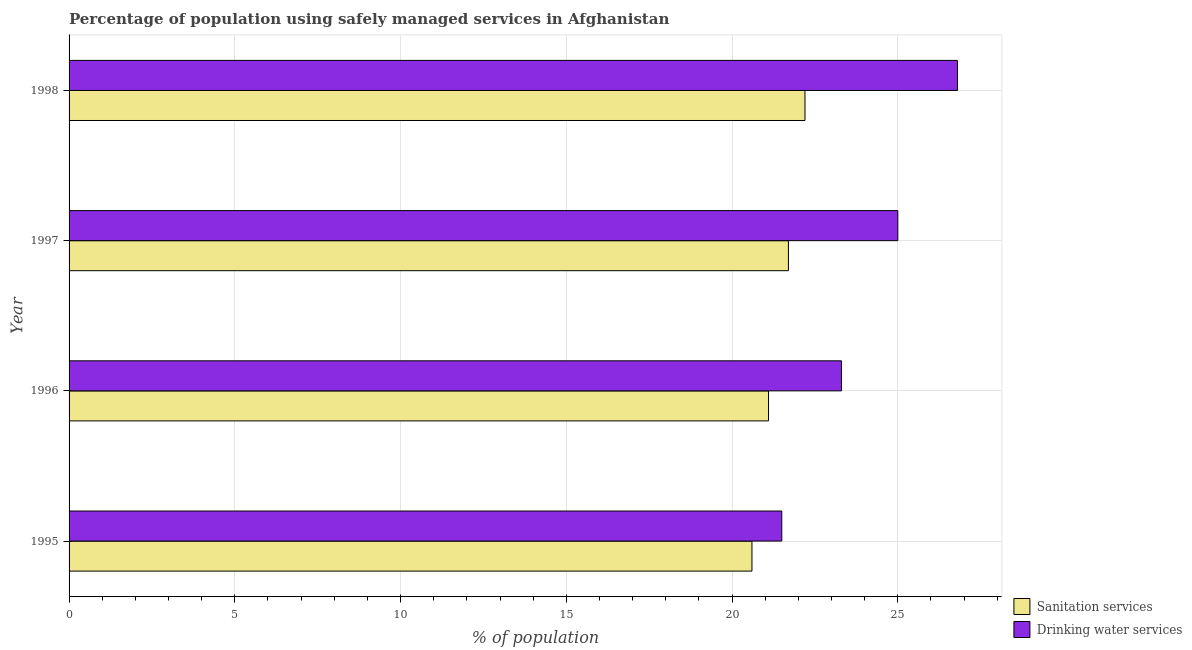How many different coloured bars are there?
Offer a very short reply. 2. Are the number of bars per tick equal to the number of legend labels?
Provide a succinct answer. Yes. Are the number of bars on each tick of the Y-axis equal?
Provide a succinct answer. Yes. In how many cases, is the number of bars for a given year not equal to the number of legend labels?
Offer a terse response. 0. What is the percentage of population who used drinking water services in 1997?
Your response must be concise. 25. Across all years, what is the maximum percentage of population who used drinking water services?
Provide a short and direct response. 26.8. Across all years, what is the minimum percentage of population who used sanitation services?
Give a very brief answer. 20.6. In which year was the percentage of population who used drinking water services minimum?
Ensure brevity in your answer.  1995. What is the total percentage of population who used sanitation services in the graph?
Offer a terse response. 85.6. What is the difference between the percentage of population who used sanitation services in 1997 and the percentage of population who used drinking water services in 1996?
Ensure brevity in your answer.  -1.6. What is the average percentage of population who used drinking water services per year?
Give a very brief answer. 24.15. In the year 1996, what is the difference between the percentage of population who used sanitation services and percentage of population who used drinking water services?
Give a very brief answer. -2.2. In how many years, is the percentage of population who used sanitation services greater than 17 %?
Make the answer very short. 4. What is the ratio of the percentage of population who used drinking water services in 1996 to that in 1997?
Your answer should be very brief. 0.93. Is the percentage of population who used sanitation services in 1995 less than that in 1998?
Offer a terse response. Yes. Is the sum of the percentage of population who used drinking water services in 1995 and 1998 greater than the maximum percentage of population who used sanitation services across all years?
Offer a very short reply. Yes. What does the 1st bar from the top in 1998 represents?
Give a very brief answer. Drinking water services. What does the 1st bar from the bottom in 1996 represents?
Offer a terse response. Sanitation services. How many bars are there?
Keep it short and to the point. 8. Are all the bars in the graph horizontal?
Ensure brevity in your answer.  Yes. How many years are there in the graph?
Your response must be concise. 4. What is the difference between two consecutive major ticks on the X-axis?
Provide a succinct answer. 5. Are the values on the major ticks of X-axis written in scientific E-notation?
Keep it short and to the point. No. Does the graph contain any zero values?
Keep it short and to the point. No. Where does the legend appear in the graph?
Offer a very short reply. Bottom right. What is the title of the graph?
Provide a succinct answer. Percentage of population using safely managed services in Afghanistan. Does "International Tourists" appear as one of the legend labels in the graph?
Your answer should be compact. No. What is the label or title of the X-axis?
Your answer should be compact. % of population. What is the % of population in Sanitation services in 1995?
Your answer should be very brief. 20.6. What is the % of population of Drinking water services in 1995?
Your answer should be very brief. 21.5. What is the % of population of Sanitation services in 1996?
Your response must be concise. 21.1. What is the % of population in Drinking water services in 1996?
Your answer should be very brief. 23.3. What is the % of population in Sanitation services in 1997?
Your answer should be very brief. 21.7. What is the % of population of Drinking water services in 1997?
Your answer should be very brief. 25. What is the % of population in Sanitation services in 1998?
Ensure brevity in your answer.  22.2. What is the % of population in Drinking water services in 1998?
Your answer should be compact. 26.8. Across all years, what is the maximum % of population of Sanitation services?
Your answer should be compact. 22.2. Across all years, what is the maximum % of population in Drinking water services?
Your response must be concise. 26.8. Across all years, what is the minimum % of population in Sanitation services?
Make the answer very short. 20.6. Across all years, what is the minimum % of population of Drinking water services?
Provide a short and direct response. 21.5. What is the total % of population in Sanitation services in the graph?
Ensure brevity in your answer.  85.6. What is the total % of population of Drinking water services in the graph?
Provide a short and direct response. 96.6. What is the difference between the % of population of Sanitation services in 1995 and that in 1998?
Offer a very short reply. -1.6. What is the difference between the % of population of Drinking water services in 1995 and that in 1998?
Your answer should be compact. -5.3. What is the difference between the % of population of Sanitation services in 1996 and that in 1997?
Give a very brief answer. -0.6. What is the difference between the % of population in Drinking water services in 1996 and that in 1997?
Your answer should be compact. -1.7. What is the difference between the % of population of Sanitation services in 1996 and that in 1998?
Ensure brevity in your answer.  -1.1. What is the difference between the % of population in Sanitation services in 1995 and the % of population in Drinking water services in 1996?
Make the answer very short. -2.7. What is the difference between the % of population of Sanitation services in 1995 and the % of population of Drinking water services in 1997?
Ensure brevity in your answer.  -4.4. What is the difference between the % of population of Sanitation services in 1995 and the % of population of Drinking water services in 1998?
Give a very brief answer. -6.2. What is the difference between the % of population of Sanitation services in 1996 and the % of population of Drinking water services in 1997?
Keep it short and to the point. -3.9. What is the average % of population of Sanitation services per year?
Make the answer very short. 21.4. What is the average % of population of Drinking water services per year?
Ensure brevity in your answer.  24.15. In the year 1997, what is the difference between the % of population in Sanitation services and % of population in Drinking water services?
Offer a terse response. -3.3. In the year 1998, what is the difference between the % of population in Sanitation services and % of population in Drinking water services?
Make the answer very short. -4.6. What is the ratio of the % of population of Sanitation services in 1995 to that in 1996?
Ensure brevity in your answer.  0.98. What is the ratio of the % of population of Drinking water services in 1995 to that in 1996?
Provide a succinct answer. 0.92. What is the ratio of the % of population in Sanitation services in 1995 to that in 1997?
Provide a short and direct response. 0.95. What is the ratio of the % of population of Drinking water services in 1995 to that in 1997?
Your answer should be very brief. 0.86. What is the ratio of the % of population of Sanitation services in 1995 to that in 1998?
Ensure brevity in your answer.  0.93. What is the ratio of the % of population of Drinking water services in 1995 to that in 1998?
Provide a short and direct response. 0.8. What is the ratio of the % of population of Sanitation services in 1996 to that in 1997?
Provide a succinct answer. 0.97. What is the ratio of the % of population in Drinking water services in 1996 to that in 1997?
Your response must be concise. 0.93. What is the ratio of the % of population of Sanitation services in 1996 to that in 1998?
Offer a terse response. 0.95. What is the ratio of the % of population of Drinking water services in 1996 to that in 1998?
Your response must be concise. 0.87. What is the ratio of the % of population in Sanitation services in 1997 to that in 1998?
Your answer should be very brief. 0.98. What is the ratio of the % of population of Drinking water services in 1997 to that in 1998?
Your answer should be compact. 0.93. What is the difference between the highest and the second highest % of population of Sanitation services?
Make the answer very short. 0.5. What is the difference between the highest and the lowest % of population of Sanitation services?
Provide a short and direct response. 1.6. What is the difference between the highest and the lowest % of population in Drinking water services?
Offer a very short reply. 5.3. 